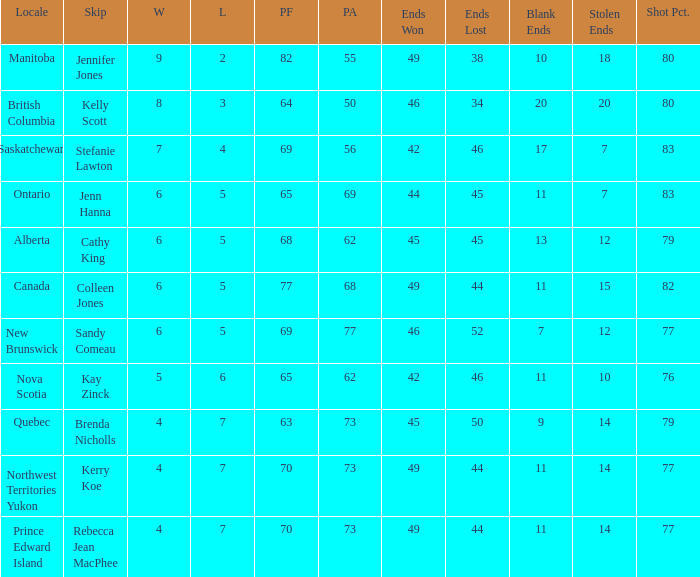If 45 ends are lost, what's the smallest pa achievable? 62.0. 